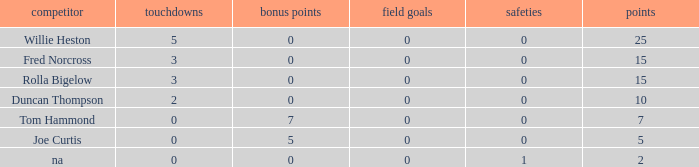Which Points is the lowest one that has Touchdowns smaller than 2, and an Extra points of 7, and a Field goals smaller than 0? None. Can you give me this table as a dict? {'header': ['competitor', 'touchdowns', 'bonus points', 'field goals', 'safeties', 'points'], 'rows': [['Willie Heston', '5', '0', '0', '0', '25'], ['Fred Norcross', '3', '0', '0', '0', '15'], ['Rolla Bigelow', '3', '0', '0', '0', '15'], ['Duncan Thompson', '2', '0', '0', '0', '10'], ['Tom Hammond', '0', '7', '0', '0', '7'], ['Joe Curtis', '0', '5', '0', '0', '5'], ['na', '0', '0', '0', '1', '2']]} 